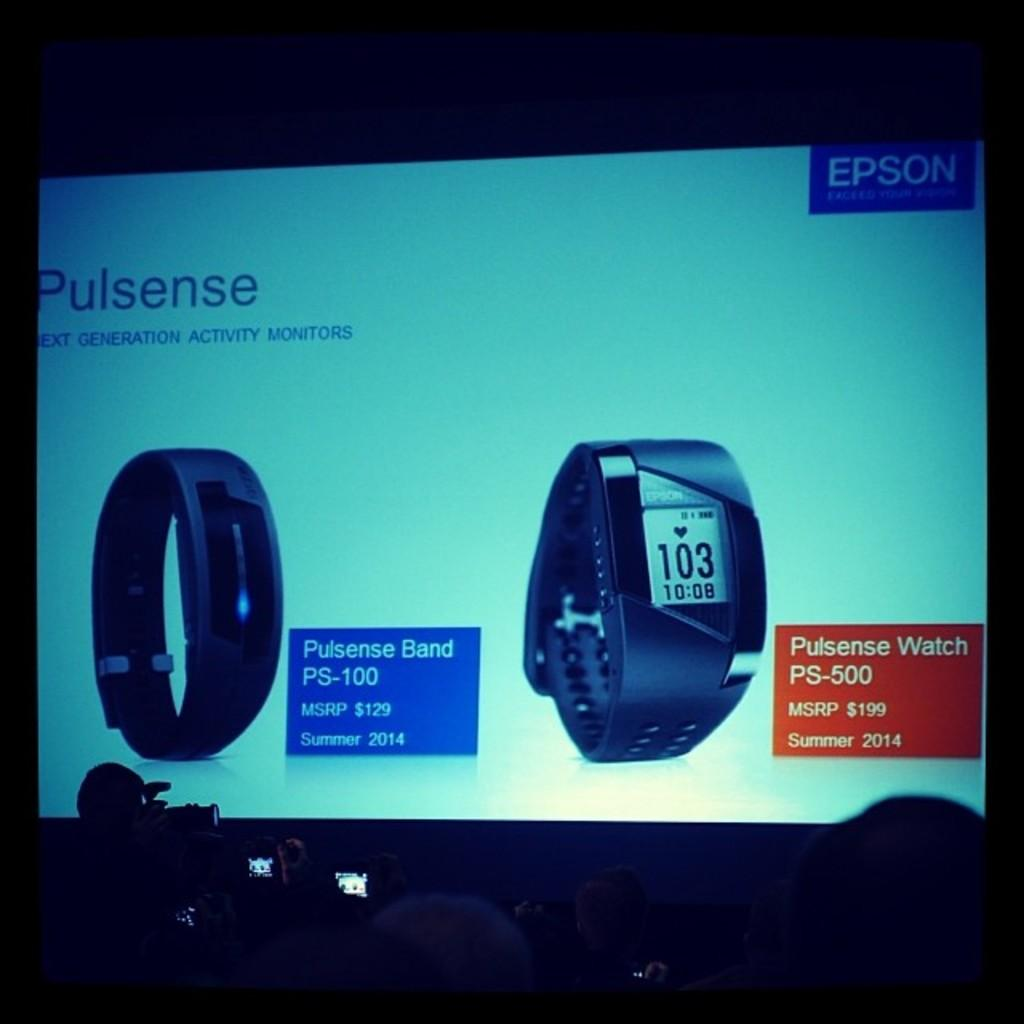<image>
Create a compact narrative representing the image presented. Screen showing watches and the word "pulsense" near the top. 